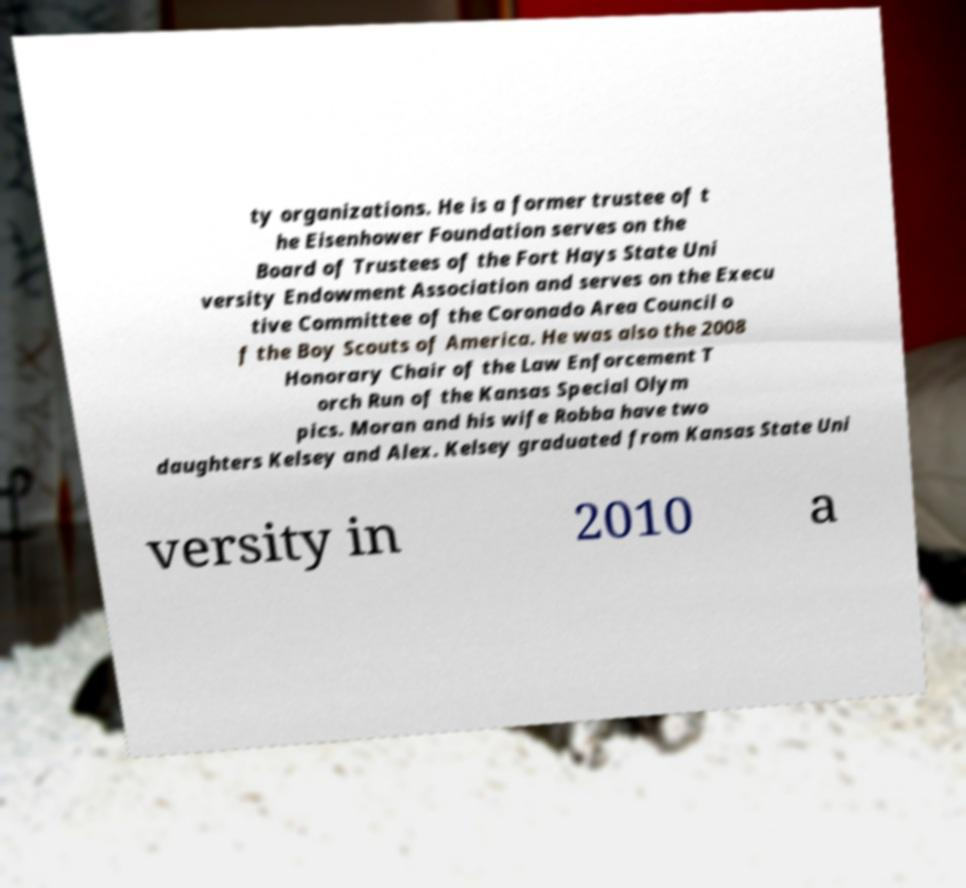What messages or text are displayed in this image? I need them in a readable, typed format. ty organizations. He is a former trustee of t he Eisenhower Foundation serves on the Board of Trustees of the Fort Hays State Uni versity Endowment Association and serves on the Execu tive Committee of the Coronado Area Council o f the Boy Scouts of America. He was also the 2008 Honorary Chair of the Law Enforcement T orch Run of the Kansas Special Olym pics. Moran and his wife Robba have two daughters Kelsey and Alex. Kelsey graduated from Kansas State Uni versity in 2010 a 